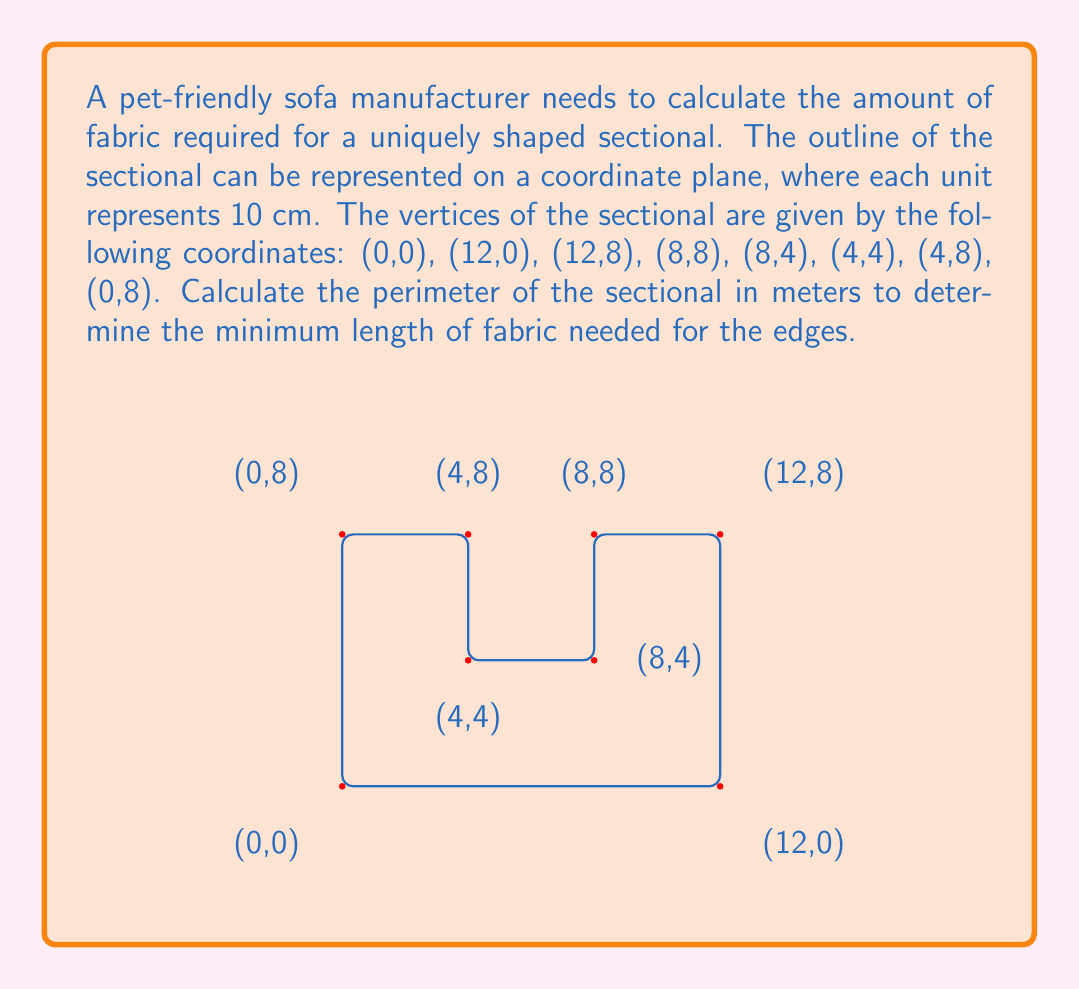Show me your answer to this math problem. To solve this problem, we need to calculate the distance between each consecutive pair of coordinates and sum them up. We'll use the distance formula between two points $(x_1, y_1)$ and $(x_2, y_2)$:

$$d = \sqrt{(x_2 - x_1)^2 + (y_2 - y_1)^2}$$

Let's calculate each segment:

1. (0,0) to (12,0): $d_1 = \sqrt{(12-0)^2 + (0-0)^2} = 12$
2. (12,0) to (12,8): $d_2 = \sqrt{(12-12)^2 + (8-0)^2} = 8$
3. (12,8) to (8,8): $d_3 = \sqrt{(8-12)^2 + (8-8)^2} = 4$
4. (8,8) to (8,4): $d_4 = \sqrt{(8-8)^2 + (4-8)^2} = 4$
5. (8,4) to (4,4): $d_5 = \sqrt{(4-8)^2 + (4-4)^2} = 4$
6. (4,4) to (4,8): $d_6 = \sqrt{(4-4)^2 + (8-4)^2} = 4$
7. (4,8) to (0,8): $d_7 = \sqrt{(0-4)^2 + (8-8)^2} = 4$
8. (0,8) to (0,0): $d_8 = \sqrt{(0-0)^2 + (0-8)^2} = 8$

Now, we sum up all these distances:

$$\text{Total distance} = 12 + 8 + 4 + 4 + 4 + 4 + 4 + 8 = 48 \text{ units}$$

Remember that each unit represents 10 cm. So, we multiply by 10 to get the result in centimeters:

$$48 \times 10 = 480 \text{ cm}$$

To convert to meters, we divide by 100:

$$480 \div 100 = 4.8 \text{ meters}$$

Therefore, the perimeter of the sectional is 4.8 meters.
Answer: 4.8 meters 